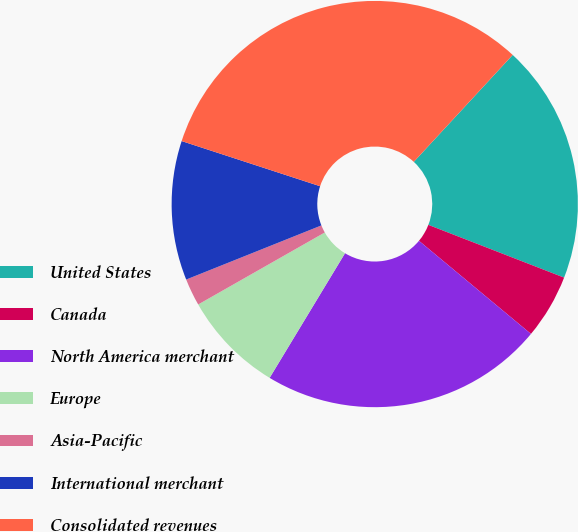Convert chart to OTSL. <chart><loc_0><loc_0><loc_500><loc_500><pie_chart><fcel>United States<fcel>Canada<fcel>North America merchant<fcel>Europe<fcel>Asia-Pacific<fcel>International merchant<fcel>Consolidated revenues<nl><fcel>19.02%<fcel>5.14%<fcel>22.62%<fcel>8.11%<fcel>2.17%<fcel>11.08%<fcel>31.86%<nl></chart> 